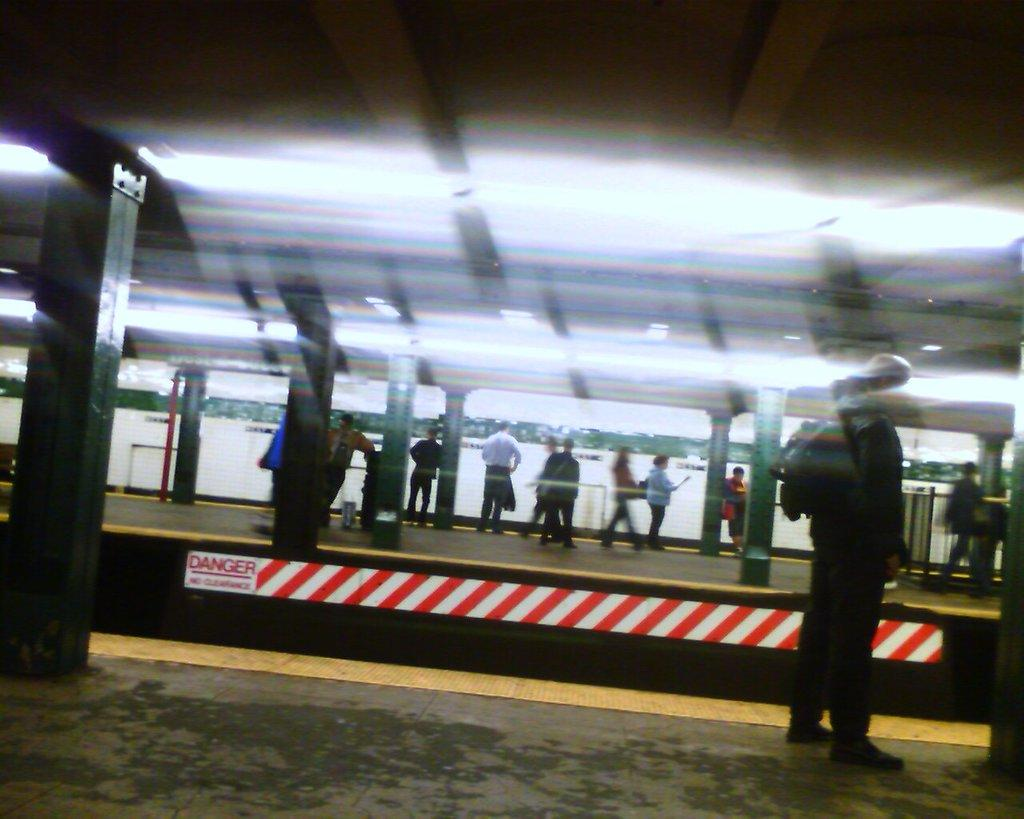What structures are present in the image? There are platforms in the image. What are people doing on the platforms? People are standing and walking on the platforms. What can be seen at the top of the image? There are lights at the top of the image. How would you describe the background of the image? The background of the image is blurred. What type of property is being offered for sale in the image? There is no property being offered for sale in the image; it features platforms with people standing and walking on them, along with lights at the top and a blurred background. 